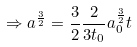<formula> <loc_0><loc_0><loc_500><loc_500>\Rightarrow { a ^ { \frac { 3 } { 2 } } } = \frac { 3 } { 2 } \frac { 2 } { 3 t _ { 0 } } a _ { 0 } ^ { \frac { 3 } { 2 } } t</formula> 